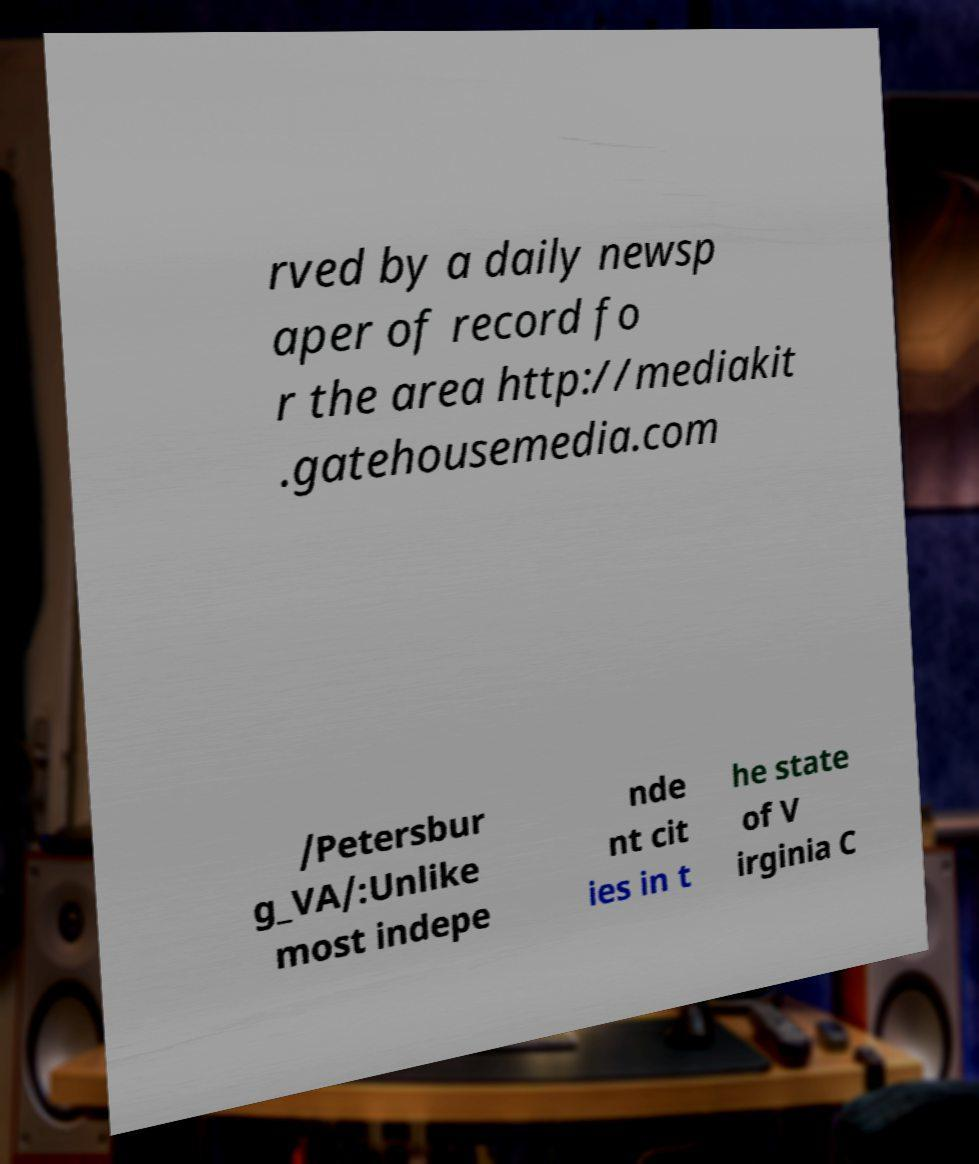What messages or text are displayed in this image? I need them in a readable, typed format. rved by a daily newsp aper of record fo r the area http://mediakit .gatehousemedia.com /Petersbur g_VA/:Unlike most indepe nde nt cit ies in t he state of V irginia C 